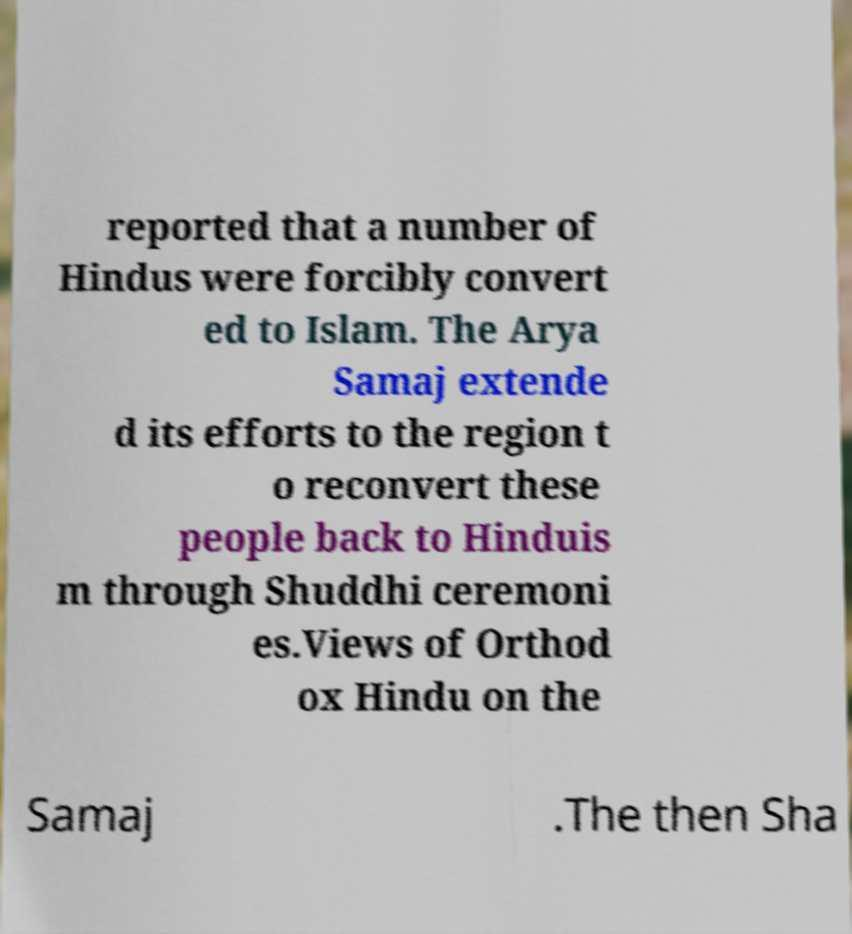Can you accurately transcribe the text from the provided image for me? reported that a number of Hindus were forcibly convert ed to Islam. The Arya Samaj extende d its efforts to the region t o reconvert these people back to Hinduis m through Shuddhi ceremoni es.Views of Orthod ox Hindu on the Samaj .The then Sha 